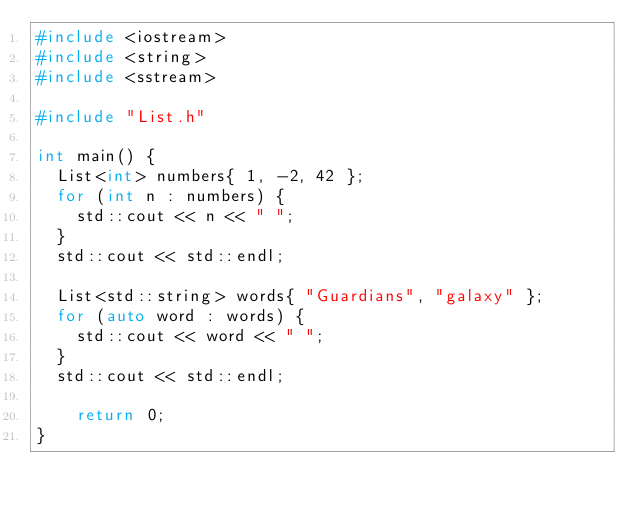Convert code to text. <code><loc_0><loc_0><loc_500><loc_500><_C++_>#include <iostream>
#include <string>
#include <sstream>

#include "List.h"

int main() {
	List<int> numbers{ 1, -2, 42 };
	for (int n : numbers) {
		std::cout << n << " ";
	}
	std::cout << std::endl;

	List<std::string> words{ "Guardians", "galaxy" };
	for (auto word : words) {
		std::cout << word << " ";
	}
	std::cout << std::endl;

    return 0;
}
</code> 